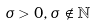<formula> <loc_0><loc_0><loc_500><loc_500>\sigma > 0 , \sigma \notin \mathbb { N }</formula> 